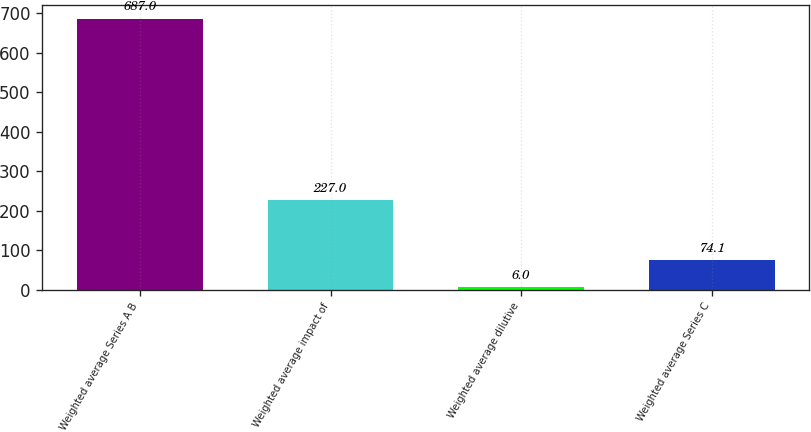<chart> <loc_0><loc_0><loc_500><loc_500><bar_chart><fcel>Weighted average Series A B<fcel>Weighted average impact of<fcel>Weighted average dilutive<fcel>Weighted average Series C<nl><fcel>687<fcel>227<fcel>6<fcel>74.1<nl></chart> 